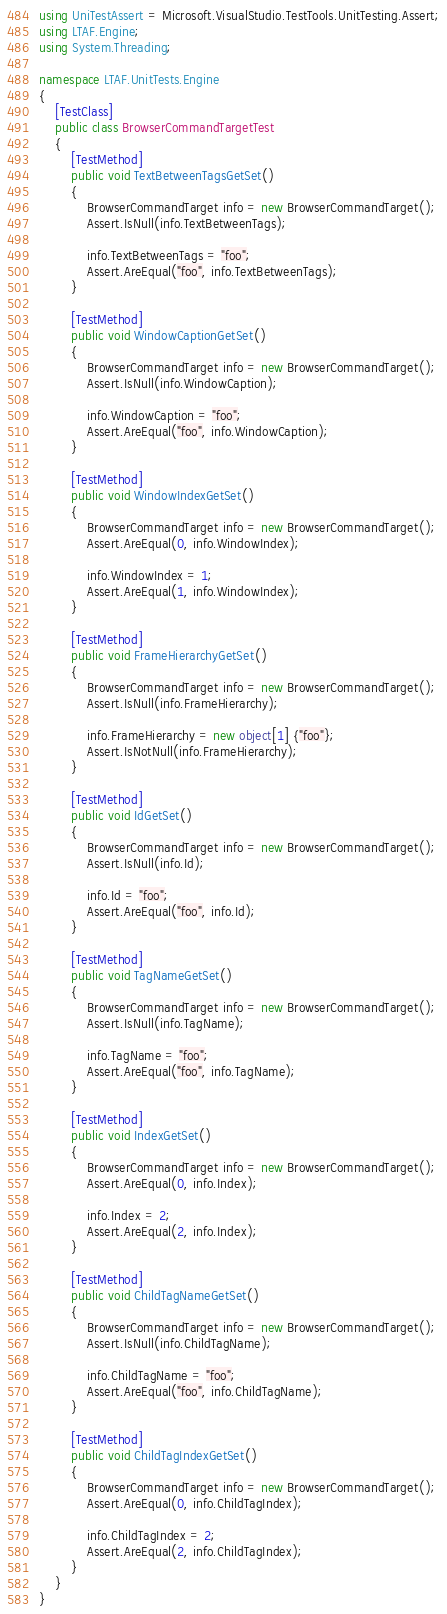<code> <loc_0><loc_0><loc_500><loc_500><_C#_>using UniTestAssert = Microsoft.VisualStudio.TestTools.UnitTesting.Assert;
using LTAF.Engine;
using System.Threading;

namespace LTAF.UnitTests.Engine
{
    [TestClass]
    public class BrowserCommandTargetTest
    {
        [TestMethod]
        public void TextBetweenTagsGetSet()
        {
            BrowserCommandTarget info = new BrowserCommandTarget();
            Assert.IsNull(info.TextBetweenTags);

            info.TextBetweenTags = "foo";
            Assert.AreEqual("foo", info.TextBetweenTags);
        }

        [TestMethod]
        public void WindowCaptionGetSet()
        {
            BrowserCommandTarget info = new BrowserCommandTarget();
            Assert.IsNull(info.WindowCaption);

            info.WindowCaption = "foo";
            Assert.AreEqual("foo", info.WindowCaption);
        }

        [TestMethod]
        public void WindowIndexGetSet()
        {
            BrowserCommandTarget info = new BrowserCommandTarget();
            Assert.AreEqual(0, info.WindowIndex);

            info.WindowIndex = 1;
            Assert.AreEqual(1, info.WindowIndex);
        }

        [TestMethod]
        public void FrameHierarchyGetSet()
        {
            BrowserCommandTarget info = new BrowserCommandTarget();
            Assert.IsNull(info.FrameHierarchy);

            info.FrameHierarchy = new object[1] {"foo"};
            Assert.IsNotNull(info.FrameHierarchy);
        }

        [TestMethod]
        public void IdGetSet()
        {
            BrowserCommandTarget info = new BrowserCommandTarget();
            Assert.IsNull(info.Id);

            info.Id = "foo";
            Assert.AreEqual("foo", info.Id);
        }

        [TestMethod]
        public void TagNameGetSet()
        {
            BrowserCommandTarget info = new BrowserCommandTarget();
            Assert.IsNull(info.TagName);

            info.TagName = "foo";
            Assert.AreEqual("foo", info.TagName);
        }

        [TestMethod]
        public void IndexGetSet()
        {
            BrowserCommandTarget info = new BrowserCommandTarget();
            Assert.AreEqual(0, info.Index);

            info.Index = 2;
            Assert.AreEqual(2, info.Index);
        }

        [TestMethod]
        public void ChildTagNameGetSet()
        {
            BrowserCommandTarget info = new BrowserCommandTarget();
            Assert.IsNull(info.ChildTagName);

            info.ChildTagName = "foo";
            Assert.AreEqual("foo", info.ChildTagName);
        }

        [TestMethod]
        public void ChildTagIndexGetSet()
        {
            BrowserCommandTarget info = new BrowserCommandTarget();
            Assert.AreEqual(0, info.ChildTagIndex);

            info.ChildTagIndex = 2;
            Assert.AreEqual(2, info.ChildTagIndex);
        }
    }
}
</code> 